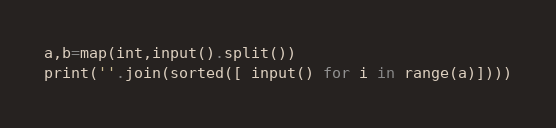<code> <loc_0><loc_0><loc_500><loc_500><_Python_>a,b=map(int,input().split())
print(''.join(sorted([ input() for i in range(a)])))
</code> 